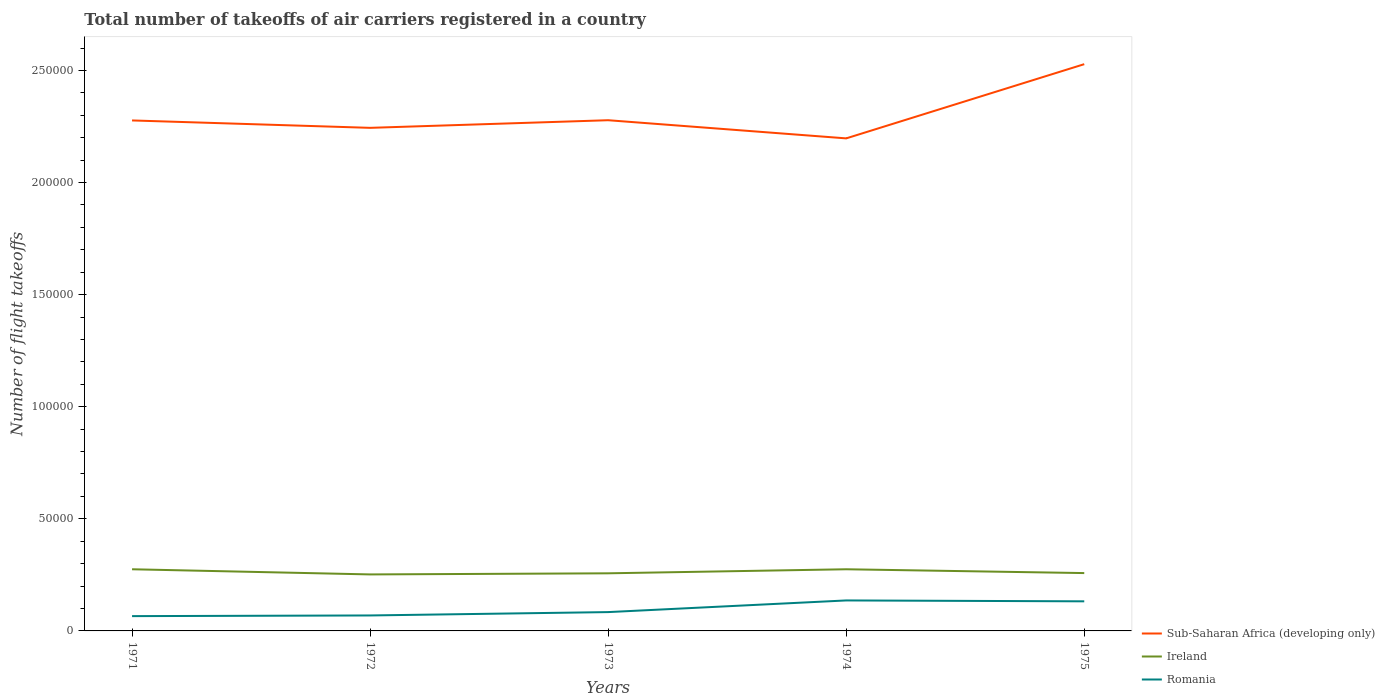How many different coloured lines are there?
Offer a terse response. 3. Is the number of lines equal to the number of legend labels?
Keep it short and to the point. Yes. Across all years, what is the maximum total number of flight takeoffs in Romania?
Your response must be concise. 6600. In which year was the total number of flight takeoffs in Romania maximum?
Offer a very short reply. 1971. What is the total total number of flight takeoffs in Ireland in the graph?
Your answer should be compact. 1700. What is the difference between the highest and the second highest total number of flight takeoffs in Romania?
Make the answer very short. 7000. What is the difference between the highest and the lowest total number of flight takeoffs in Ireland?
Your answer should be very brief. 2. Is the total number of flight takeoffs in Romania strictly greater than the total number of flight takeoffs in Sub-Saharan Africa (developing only) over the years?
Provide a short and direct response. Yes. How many lines are there?
Ensure brevity in your answer.  3. How many years are there in the graph?
Your answer should be very brief. 5. How are the legend labels stacked?
Keep it short and to the point. Vertical. What is the title of the graph?
Offer a terse response. Total number of takeoffs of air carriers registered in a country. Does "Bangladesh" appear as one of the legend labels in the graph?
Make the answer very short. No. What is the label or title of the Y-axis?
Give a very brief answer. Number of flight takeoffs. What is the Number of flight takeoffs in Sub-Saharan Africa (developing only) in 1971?
Offer a terse response. 2.28e+05. What is the Number of flight takeoffs in Ireland in 1971?
Offer a very short reply. 2.75e+04. What is the Number of flight takeoffs in Romania in 1971?
Keep it short and to the point. 6600. What is the Number of flight takeoffs in Sub-Saharan Africa (developing only) in 1972?
Offer a very short reply. 2.24e+05. What is the Number of flight takeoffs in Ireland in 1972?
Keep it short and to the point. 2.52e+04. What is the Number of flight takeoffs of Romania in 1972?
Ensure brevity in your answer.  6900. What is the Number of flight takeoffs in Sub-Saharan Africa (developing only) in 1973?
Make the answer very short. 2.28e+05. What is the Number of flight takeoffs of Ireland in 1973?
Your answer should be very brief. 2.57e+04. What is the Number of flight takeoffs of Romania in 1973?
Provide a short and direct response. 8400. What is the Number of flight takeoffs of Sub-Saharan Africa (developing only) in 1974?
Make the answer very short. 2.20e+05. What is the Number of flight takeoffs of Ireland in 1974?
Provide a succinct answer. 2.75e+04. What is the Number of flight takeoffs of Romania in 1974?
Ensure brevity in your answer.  1.36e+04. What is the Number of flight takeoffs of Sub-Saharan Africa (developing only) in 1975?
Offer a terse response. 2.53e+05. What is the Number of flight takeoffs of Ireland in 1975?
Keep it short and to the point. 2.58e+04. What is the Number of flight takeoffs in Romania in 1975?
Provide a short and direct response. 1.32e+04. Across all years, what is the maximum Number of flight takeoffs in Sub-Saharan Africa (developing only)?
Your answer should be compact. 2.53e+05. Across all years, what is the maximum Number of flight takeoffs in Ireland?
Provide a short and direct response. 2.75e+04. Across all years, what is the maximum Number of flight takeoffs of Romania?
Provide a short and direct response. 1.36e+04. Across all years, what is the minimum Number of flight takeoffs in Sub-Saharan Africa (developing only)?
Your answer should be very brief. 2.20e+05. Across all years, what is the minimum Number of flight takeoffs of Ireland?
Your response must be concise. 2.52e+04. Across all years, what is the minimum Number of flight takeoffs of Romania?
Make the answer very short. 6600. What is the total Number of flight takeoffs of Sub-Saharan Africa (developing only) in the graph?
Your response must be concise. 1.15e+06. What is the total Number of flight takeoffs in Ireland in the graph?
Keep it short and to the point. 1.32e+05. What is the total Number of flight takeoffs in Romania in the graph?
Provide a short and direct response. 4.87e+04. What is the difference between the Number of flight takeoffs of Sub-Saharan Africa (developing only) in 1971 and that in 1972?
Offer a terse response. 3300. What is the difference between the Number of flight takeoffs of Ireland in 1971 and that in 1972?
Give a very brief answer. 2300. What is the difference between the Number of flight takeoffs in Romania in 1971 and that in 1972?
Give a very brief answer. -300. What is the difference between the Number of flight takeoffs of Sub-Saharan Africa (developing only) in 1971 and that in 1973?
Your answer should be compact. -100. What is the difference between the Number of flight takeoffs in Ireland in 1971 and that in 1973?
Offer a very short reply. 1800. What is the difference between the Number of flight takeoffs of Romania in 1971 and that in 1973?
Offer a very short reply. -1800. What is the difference between the Number of flight takeoffs in Sub-Saharan Africa (developing only) in 1971 and that in 1974?
Your response must be concise. 8000. What is the difference between the Number of flight takeoffs in Romania in 1971 and that in 1974?
Provide a short and direct response. -7000. What is the difference between the Number of flight takeoffs in Sub-Saharan Africa (developing only) in 1971 and that in 1975?
Your response must be concise. -2.51e+04. What is the difference between the Number of flight takeoffs in Ireland in 1971 and that in 1975?
Offer a terse response. 1700. What is the difference between the Number of flight takeoffs in Romania in 1971 and that in 1975?
Ensure brevity in your answer.  -6600. What is the difference between the Number of flight takeoffs of Sub-Saharan Africa (developing only) in 1972 and that in 1973?
Provide a short and direct response. -3400. What is the difference between the Number of flight takeoffs in Ireland in 1972 and that in 1973?
Provide a succinct answer. -500. What is the difference between the Number of flight takeoffs of Romania in 1972 and that in 1973?
Provide a succinct answer. -1500. What is the difference between the Number of flight takeoffs in Sub-Saharan Africa (developing only) in 1972 and that in 1974?
Provide a short and direct response. 4700. What is the difference between the Number of flight takeoffs in Ireland in 1972 and that in 1974?
Keep it short and to the point. -2300. What is the difference between the Number of flight takeoffs of Romania in 1972 and that in 1974?
Your answer should be very brief. -6700. What is the difference between the Number of flight takeoffs of Sub-Saharan Africa (developing only) in 1972 and that in 1975?
Provide a short and direct response. -2.84e+04. What is the difference between the Number of flight takeoffs in Ireland in 1972 and that in 1975?
Your response must be concise. -600. What is the difference between the Number of flight takeoffs of Romania in 1972 and that in 1975?
Provide a succinct answer. -6300. What is the difference between the Number of flight takeoffs in Sub-Saharan Africa (developing only) in 1973 and that in 1974?
Your response must be concise. 8100. What is the difference between the Number of flight takeoffs of Ireland in 1973 and that in 1974?
Offer a terse response. -1800. What is the difference between the Number of flight takeoffs in Romania in 1973 and that in 1974?
Provide a succinct answer. -5200. What is the difference between the Number of flight takeoffs of Sub-Saharan Africa (developing only) in 1973 and that in 1975?
Provide a succinct answer. -2.50e+04. What is the difference between the Number of flight takeoffs in Ireland in 1973 and that in 1975?
Your response must be concise. -100. What is the difference between the Number of flight takeoffs of Romania in 1973 and that in 1975?
Provide a short and direct response. -4800. What is the difference between the Number of flight takeoffs in Sub-Saharan Africa (developing only) in 1974 and that in 1975?
Your response must be concise. -3.31e+04. What is the difference between the Number of flight takeoffs in Ireland in 1974 and that in 1975?
Keep it short and to the point. 1700. What is the difference between the Number of flight takeoffs in Sub-Saharan Africa (developing only) in 1971 and the Number of flight takeoffs in Ireland in 1972?
Keep it short and to the point. 2.02e+05. What is the difference between the Number of flight takeoffs of Sub-Saharan Africa (developing only) in 1971 and the Number of flight takeoffs of Romania in 1972?
Make the answer very short. 2.21e+05. What is the difference between the Number of flight takeoffs of Ireland in 1971 and the Number of flight takeoffs of Romania in 1972?
Provide a short and direct response. 2.06e+04. What is the difference between the Number of flight takeoffs of Sub-Saharan Africa (developing only) in 1971 and the Number of flight takeoffs of Ireland in 1973?
Offer a very short reply. 2.02e+05. What is the difference between the Number of flight takeoffs of Sub-Saharan Africa (developing only) in 1971 and the Number of flight takeoffs of Romania in 1973?
Your answer should be compact. 2.19e+05. What is the difference between the Number of flight takeoffs in Ireland in 1971 and the Number of flight takeoffs in Romania in 1973?
Give a very brief answer. 1.91e+04. What is the difference between the Number of flight takeoffs of Sub-Saharan Africa (developing only) in 1971 and the Number of flight takeoffs of Ireland in 1974?
Your answer should be very brief. 2.00e+05. What is the difference between the Number of flight takeoffs in Sub-Saharan Africa (developing only) in 1971 and the Number of flight takeoffs in Romania in 1974?
Offer a terse response. 2.14e+05. What is the difference between the Number of flight takeoffs of Ireland in 1971 and the Number of flight takeoffs of Romania in 1974?
Your response must be concise. 1.39e+04. What is the difference between the Number of flight takeoffs of Sub-Saharan Africa (developing only) in 1971 and the Number of flight takeoffs of Ireland in 1975?
Ensure brevity in your answer.  2.02e+05. What is the difference between the Number of flight takeoffs in Sub-Saharan Africa (developing only) in 1971 and the Number of flight takeoffs in Romania in 1975?
Offer a very short reply. 2.14e+05. What is the difference between the Number of flight takeoffs in Ireland in 1971 and the Number of flight takeoffs in Romania in 1975?
Make the answer very short. 1.43e+04. What is the difference between the Number of flight takeoffs of Sub-Saharan Africa (developing only) in 1972 and the Number of flight takeoffs of Ireland in 1973?
Your answer should be compact. 1.99e+05. What is the difference between the Number of flight takeoffs in Sub-Saharan Africa (developing only) in 1972 and the Number of flight takeoffs in Romania in 1973?
Offer a terse response. 2.16e+05. What is the difference between the Number of flight takeoffs in Ireland in 1972 and the Number of flight takeoffs in Romania in 1973?
Your response must be concise. 1.68e+04. What is the difference between the Number of flight takeoffs of Sub-Saharan Africa (developing only) in 1972 and the Number of flight takeoffs of Ireland in 1974?
Your answer should be compact. 1.97e+05. What is the difference between the Number of flight takeoffs of Sub-Saharan Africa (developing only) in 1972 and the Number of flight takeoffs of Romania in 1974?
Ensure brevity in your answer.  2.11e+05. What is the difference between the Number of flight takeoffs in Ireland in 1972 and the Number of flight takeoffs in Romania in 1974?
Ensure brevity in your answer.  1.16e+04. What is the difference between the Number of flight takeoffs of Sub-Saharan Africa (developing only) in 1972 and the Number of flight takeoffs of Ireland in 1975?
Make the answer very short. 1.99e+05. What is the difference between the Number of flight takeoffs of Sub-Saharan Africa (developing only) in 1972 and the Number of flight takeoffs of Romania in 1975?
Provide a short and direct response. 2.11e+05. What is the difference between the Number of flight takeoffs in Ireland in 1972 and the Number of flight takeoffs in Romania in 1975?
Make the answer very short. 1.20e+04. What is the difference between the Number of flight takeoffs of Sub-Saharan Africa (developing only) in 1973 and the Number of flight takeoffs of Ireland in 1974?
Give a very brief answer. 2.00e+05. What is the difference between the Number of flight takeoffs in Sub-Saharan Africa (developing only) in 1973 and the Number of flight takeoffs in Romania in 1974?
Provide a succinct answer. 2.14e+05. What is the difference between the Number of flight takeoffs of Ireland in 1973 and the Number of flight takeoffs of Romania in 1974?
Ensure brevity in your answer.  1.21e+04. What is the difference between the Number of flight takeoffs of Sub-Saharan Africa (developing only) in 1973 and the Number of flight takeoffs of Ireland in 1975?
Your response must be concise. 2.02e+05. What is the difference between the Number of flight takeoffs in Sub-Saharan Africa (developing only) in 1973 and the Number of flight takeoffs in Romania in 1975?
Your answer should be very brief. 2.15e+05. What is the difference between the Number of flight takeoffs in Ireland in 1973 and the Number of flight takeoffs in Romania in 1975?
Your response must be concise. 1.25e+04. What is the difference between the Number of flight takeoffs of Sub-Saharan Africa (developing only) in 1974 and the Number of flight takeoffs of Ireland in 1975?
Your answer should be compact. 1.94e+05. What is the difference between the Number of flight takeoffs of Sub-Saharan Africa (developing only) in 1974 and the Number of flight takeoffs of Romania in 1975?
Give a very brief answer. 2.06e+05. What is the difference between the Number of flight takeoffs of Ireland in 1974 and the Number of flight takeoffs of Romania in 1975?
Your response must be concise. 1.43e+04. What is the average Number of flight takeoffs in Sub-Saharan Africa (developing only) per year?
Offer a very short reply. 2.30e+05. What is the average Number of flight takeoffs in Ireland per year?
Ensure brevity in your answer.  2.63e+04. What is the average Number of flight takeoffs in Romania per year?
Your response must be concise. 9740. In the year 1971, what is the difference between the Number of flight takeoffs in Sub-Saharan Africa (developing only) and Number of flight takeoffs in Ireland?
Your answer should be very brief. 2.00e+05. In the year 1971, what is the difference between the Number of flight takeoffs in Sub-Saharan Africa (developing only) and Number of flight takeoffs in Romania?
Provide a succinct answer. 2.21e+05. In the year 1971, what is the difference between the Number of flight takeoffs in Ireland and Number of flight takeoffs in Romania?
Offer a terse response. 2.09e+04. In the year 1972, what is the difference between the Number of flight takeoffs in Sub-Saharan Africa (developing only) and Number of flight takeoffs in Ireland?
Ensure brevity in your answer.  1.99e+05. In the year 1972, what is the difference between the Number of flight takeoffs in Sub-Saharan Africa (developing only) and Number of flight takeoffs in Romania?
Provide a short and direct response. 2.18e+05. In the year 1972, what is the difference between the Number of flight takeoffs of Ireland and Number of flight takeoffs of Romania?
Keep it short and to the point. 1.83e+04. In the year 1973, what is the difference between the Number of flight takeoffs of Sub-Saharan Africa (developing only) and Number of flight takeoffs of Ireland?
Offer a terse response. 2.02e+05. In the year 1973, what is the difference between the Number of flight takeoffs in Sub-Saharan Africa (developing only) and Number of flight takeoffs in Romania?
Your answer should be compact. 2.19e+05. In the year 1973, what is the difference between the Number of flight takeoffs in Ireland and Number of flight takeoffs in Romania?
Provide a short and direct response. 1.73e+04. In the year 1974, what is the difference between the Number of flight takeoffs in Sub-Saharan Africa (developing only) and Number of flight takeoffs in Ireland?
Offer a very short reply. 1.92e+05. In the year 1974, what is the difference between the Number of flight takeoffs of Sub-Saharan Africa (developing only) and Number of flight takeoffs of Romania?
Offer a very short reply. 2.06e+05. In the year 1974, what is the difference between the Number of flight takeoffs of Ireland and Number of flight takeoffs of Romania?
Provide a succinct answer. 1.39e+04. In the year 1975, what is the difference between the Number of flight takeoffs of Sub-Saharan Africa (developing only) and Number of flight takeoffs of Ireland?
Ensure brevity in your answer.  2.27e+05. In the year 1975, what is the difference between the Number of flight takeoffs of Sub-Saharan Africa (developing only) and Number of flight takeoffs of Romania?
Your answer should be very brief. 2.40e+05. In the year 1975, what is the difference between the Number of flight takeoffs of Ireland and Number of flight takeoffs of Romania?
Keep it short and to the point. 1.26e+04. What is the ratio of the Number of flight takeoffs of Sub-Saharan Africa (developing only) in 1971 to that in 1972?
Offer a very short reply. 1.01. What is the ratio of the Number of flight takeoffs in Ireland in 1971 to that in 1972?
Your response must be concise. 1.09. What is the ratio of the Number of flight takeoffs in Romania in 1971 to that in 1972?
Give a very brief answer. 0.96. What is the ratio of the Number of flight takeoffs in Sub-Saharan Africa (developing only) in 1971 to that in 1973?
Make the answer very short. 1. What is the ratio of the Number of flight takeoffs in Ireland in 1971 to that in 1973?
Offer a very short reply. 1.07. What is the ratio of the Number of flight takeoffs in Romania in 1971 to that in 1973?
Provide a succinct answer. 0.79. What is the ratio of the Number of flight takeoffs in Sub-Saharan Africa (developing only) in 1971 to that in 1974?
Provide a short and direct response. 1.04. What is the ratio of the Number of flight takeoffs in Ireland in 1971 to that in 1974?
Offer a terse response. 1. What is the ratio of the Number of flight takeoffs in Romania in 1971 to that in 1974?
Provide a short and direct response. 0.49. What is the ratio of the Number of flight takeoffs of Sub-Saharan Africa (developing only) in 1971 to that in 1975?
Make the answer very short. 0.9. What is the ratio of the Number of flight takeoffs in Ireland in 1971 to that in 1975?
Your answer should be compact. 1.07. What is the ratio of the Number of flight takeoffs of Romania in 1971 to that in 1975?
Your answer should be very brief. 0.5. What is the ratio of the Number of flight takeoffs in Sub-Saharan Africa (developing only) in 1972 to that in 1973?
Give a very brief answer. 0.99. What is the ratio of the Number of flight takeoffs in Ireland in 1972 to that in 1973?
Offer a very short reply. 0.98. What is the ratio of the Number of flight takeoffs in Romania in 1972 to that in 1973?
Offer a very short reply. 0.82. What is the ratio of the Number of flight takeoffs of Sub-Saharan Africa (developing only) in 1972 to that in 1974?
Provide a succinct answer. 1.02. What is the ratio of the Number of flight takeoffs of Ireland in 1972 to that in 1974?
Provide a short and direct response. 0.92. What is the ratio of the Number of flight takeoffs of Romania in 1972 to that in 1974?
Ensure brevity in your answer.  0.51. What is the ratio of the Number of flight takeoffs in Sub-Saharan Africa (developing only) in 1972 to that in 1975?
Give a very brief answer. 0.89. What is the ratio of the Number of flight takeoffs in Ireland in 1972 to that in 1975?
Offer a very short reply. 0.98. What is the ratio of the Number of flight takeoffs of Romania in 1972 to that in 1975?
Make the answer very short. 0.52. What is the ratio of the Number of flight takeoffs of Sub-Saharan Africa (developing only) in 1973 to that in 1974?
Provide a short and direct response. 1.04. What is the ratio of the Number of flight takeoffs in Ireland in 1973 to that in 1974?
Give a very brief answer. 0.93. What is the ratio of the Number of flight takeoffs in Romania in 1973 to that in 1974?
Offer a very short reply. 0.62. What is the ratio of the Number of flight takeoffs of Sub-Saharan Africa (developing only) in 1973 to that in 1975?
Keep it short and to the point. 0.9. What is the ratio of the Number of flight takeoffs in Romania in 1973 to that in 1975?
Your answer should be compact. 0.64. What is the ratio of the Number of flight takeoffs in Sub-Saharan Africa (developing only) in 1974 to that in 1975?
Your answer should be very brief. 0.87. What is the ratio of the Number of flight takeoffs in Ireland in 1974 to that in 1975?
Your answer should be compact. 1.07. What is the ratio of the Number of flight takeoffs in Romania in 1974 to that in 1975?
Your response must be concise. 1.03. What is the difference between the highest and the second highest Number of flight takeoffs of Sub-Saharan Africa (developing only)?
Give a very brief answer. 2.50e+04. What is the difference between the highest and the lowest Number of flight takeoffs of Sub-Saharan Africa (developing only)?
Your answer should be very brief. 3.31e+04. What is the difference between the highest and the lowest Number of flight takeoffs of Ireland?
Provide a short and direct response. 2300. What is the difference between the highest and the lowest Number of flight takeoffs of Romania?
Your response must be concise. 7000. 